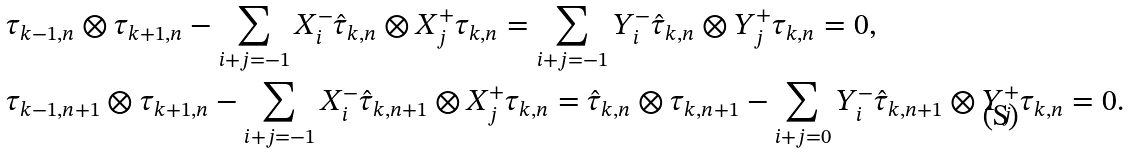<formula> <loc_0><loc_0><loc_500><loc_500>& \tau _ { k - 1 , n } \otimes \tau _ { k + 1 , n } - \sum _ { i + j = - 1 } X _ { i } ^ { - } \hat { \tau } _ { k , n } \otimes X _ { j } ^ { + } \tau _ { k , n } = \sum _ { i + j = - 1 } Y _ { i } ^ { - } \hat { \tau } _ { k , n } \otimes Y _ { j } ^ { + } \tau _ { k , n } = 0 , \\ & \tau _ { k - 1 , n + 1 } \otimes \tau _ { k + 1 , n } - \sum _ { i + j = - 1 } X _ { i } ^ { - } \hat { \tau } _ { k , n + 1 } \otimes X _ { j } ^ { + } \tau _ { k , n } = \hat { \tau } _ { k , n } \otimes \tau _ { k , n + 1 } - \sum _ { i + j = 0 } Y _ { i } ^ { - } \hat { \tau } _ { k , n + 1 } \otimes Y _ { j } ^ { + } \tau _ { k , n } = 0 .</formula> 